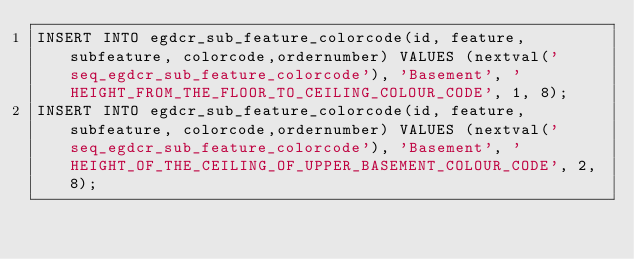Convert code to text. <code><loc_0><loc_0><loc_500><loc_500><_SQL_>INSERT INTO egdcr_sub_feature_colorcode(id, feature, subfeature, colorcode,ordernumber) VALUES (nextval('seq_egdcr_sub_feature_colorcode'), 'Basement', 'HEIGHT_FROM_THE_FLOOR_TO_CEILING_COLOUR_CODE', 1, 8);
INSERT INTO egdcr_sub_feature_colorcode(id, feature, subfeature, colorcode,ordernumber) VALUES (nextval('seq_egdcr_sub_feature_colorcode'), 'Basement', 'HEIGHT_OF_THE_CEILING_OF_UPPER_BASEMENT_COLOUR_CODE', 2, 8);</code> 